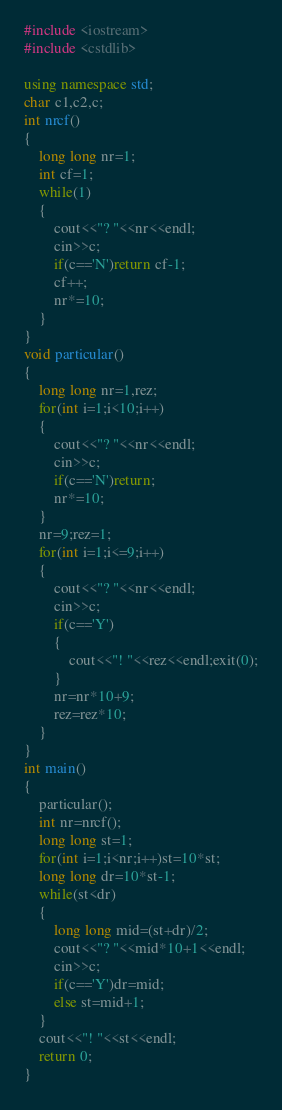<code> <loc_0><loc_0><loc_500><loc_500><_C++_>#include <iostream>
#include <cstdlib>

using namespace std;
char c1,c2,c;
int nrcf()
{
    long long nr=1;
    int cf=1;
    while(1)
    {
        cout<<"? "<<nr<<endl;
        cin>>c;
        if(c=='N')return cf-1;
        cf++;
        nr*=10;
    }
}
void particular()
{
    long long nr=1,rez;
    for(int i=1;i<10;i++)
    {
        cout<<"? "<<nr<<endl;
        cin>>c;
        if(c=='N')return;
        nr*=10;
    }
    nr=9;rez=1;
    for(int i=1;i<=9;i++)
    {
        cout<<"? "<<nr<<endl;
        cin>>c;
        if(c=='Y')
        {
            cout<<"! "<<rez<<endl;exit(0);
        }
        nr=nr*10+9;
        rez=rez*10;
    }
}
int main()
{
    particular();
    int nr=nrcf();
    long long st=1;
    for(int i=1;i<nr;i++)st=10*st;
    long long dr=10*st-1;
    while(st<dr)
    {
        long long mid=(st+dr)/2;
        cout<<"? "<<mid*10+1<<endl;
        cin>>c;
        if(c=='Y')dr=mid;
        else st=mid+1;
    }
    cout<<"! "<<st<<endl;
    return 0;
}
</code> 